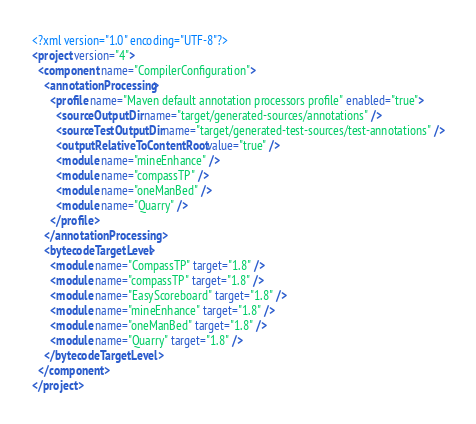<code> <loc_0><loc_0><loc_500><loc_500><_XML_><?xml version="1.0" encoding="UTF-8"?>
<project version="4">
  <component name="CompilerConfiguration">
    <annotationProcessing>
      <profile name="Maven default annotation processors profile" enabled="true">
        <sourceOutputDir name="target/generated-sources/annotations" />
        <sourceTestOutputDir name="target/generated-test-sources/test-annotations" />
        <outputRelativeToContentRoot value="true" />
        <module name="mineEnhance" />
        <module name="compassTP" />
        <module name="oneManBed" />
        <module name="Quarry" />
      </profile>
    </annotationProcessing>
    <bytecodeTargetLevel>
      <module name="CompassTP" target="1.8" />
      <module name="compassTP" target="1.8" />
      <module name="EasyScoreboard" target="1.8" />
      <module name="mineEnhance" target="1.8" />
      <module name="oneManBed" target="1.8" />
      <module name="Quarry" target="1.8" />
    </bytecodeTargetLevel>
  </component>
</project></code> 